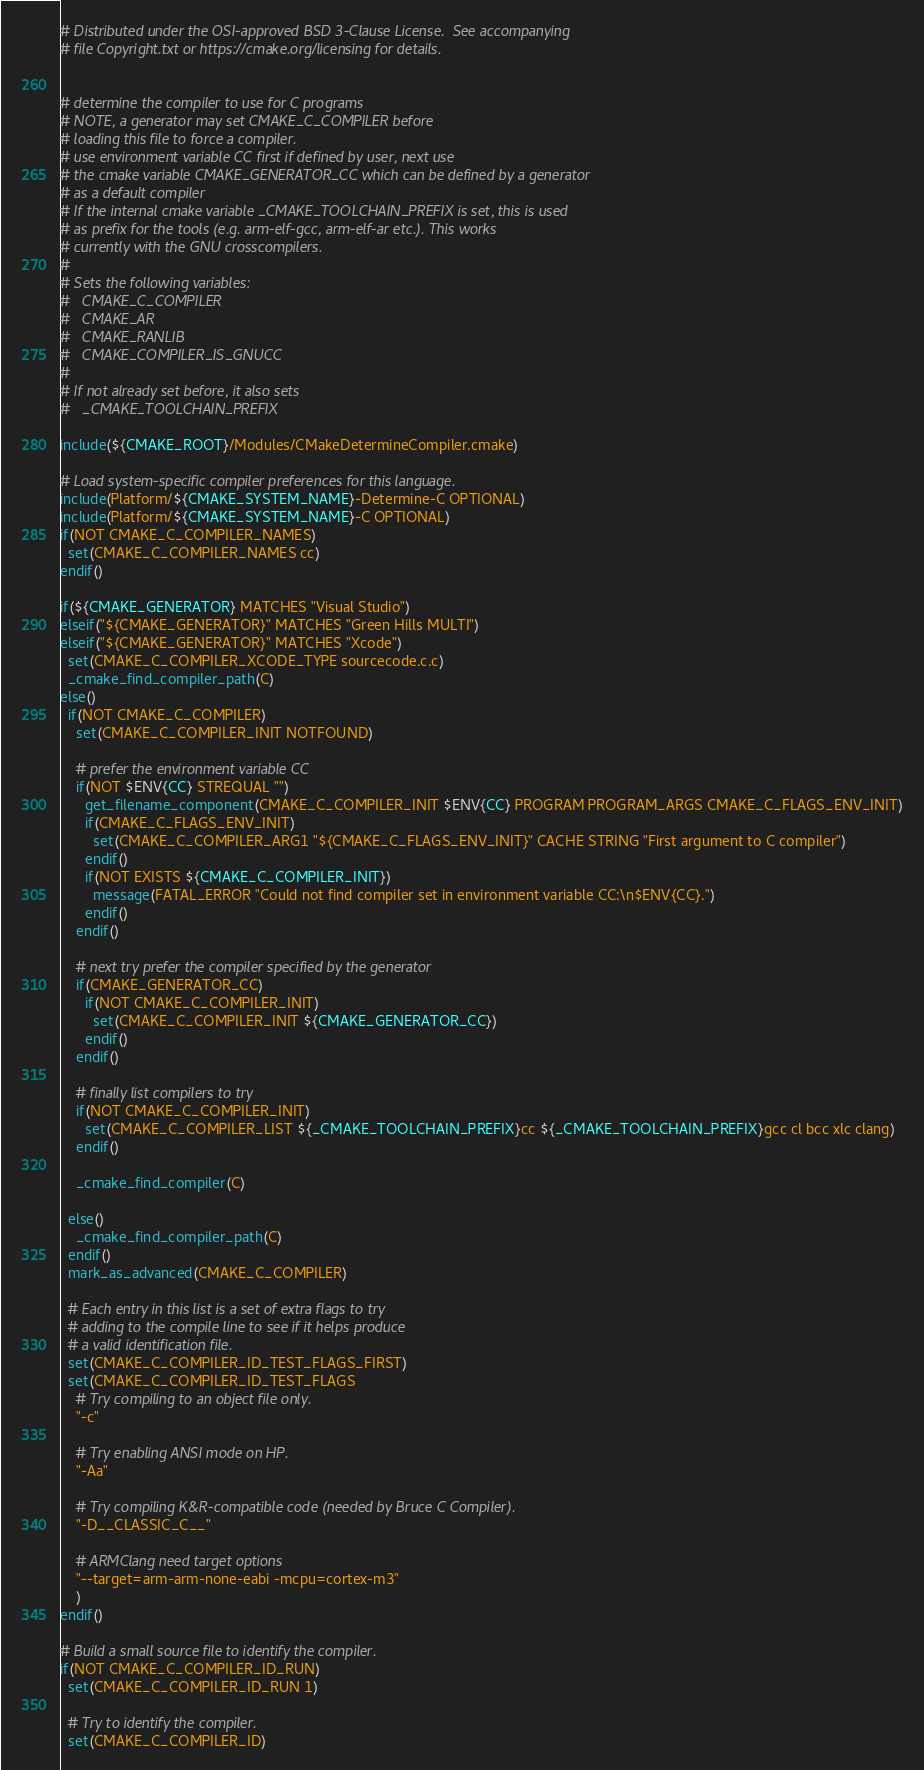<code> <loc_0><loc_0><loc_500><loc_500><_CMake_># Distributed under the OSI-approved BSD 3-Clause License.  See accompanying
# file Copyright.txt or https://cmake.org/licensing for details.


# determine the compiler to use for C programs
# NOTE, a generator may set CMAKE_C_COMPILER before
# loading this file to force a compiler.
# use environment variable CC first if defined by user, next use
# the cmake variable CMAKE_GENERATOR_CC which can be defined by a generator
# as a default compiler
# If the internal cmake variable _CMAKE_TOOLCHAIN_PREFIX is set, this is used
# as prefix for the tools (e.g. arm-elf-gcc, arm-elf-ar etc.). This works
# currently with the GNU crosscompilers.
#
# Sets the following variables:
#   CMAKE_C_COMPILER
#   CMAKE_AR
#   CMAKE_RANLIB
#   CMAKE_COMPILER_IS_GNUCC
#
# If not already set before, it also sets
#   _CMAKE_TOOLCHAIN_PREFIX

include(${CMAKE_ROOT}/Modules/CMakeDetermineCompiler.cmake)

# Load system-specific compiler preferences for this language.
include(Platform/${CMAKE_SYSTEM_NAME}-Determine-C OPTIONAL)
include(Platform/${CMAKE_SYSTEM_NAME}-C OPTIONAL)
if(NOT CMAKE_C_COMPILER_NAMES)
  set(CMAKE_C_COMPILER_NAMES cc)
endif()

if(${CMAKE_GENERATOR} MATCHES "Visual Studio")
elseif("${CMAKE_GENERATOR}" MATCHES "Green Hills MULTI")
elseif("${CMAKE_GENERATOR}" MATCHES "Xcode")
  set(CMAKE_C_COMPILER_XCODE_TYPE sourcecode.c.c)
  _cmake_find_compiler_path(C)
else()
  if(NOT CMAKE_C_COMPILER)
    set(CMAKE_C_COMPILER_INIT NOTFOUND)

    # prefer the environment variable CC
    if(NOT $ENV{CC} STREQUAL "")
      get_filename_component(CMAKE_C_COMPILER_INIT $ENV{CC} PROGRAM PROGRAM_ARGS CMAKE_C_FLAGS_ENV_INIT)
      if(CMAKE_C_FLAGS_ENV_INIT)
        set(CMAKE_C_COMPILER_ARG1 "${CMAKE_C_FLAGS_ENV_INIT}" CACHE STRING "First argument to C compiler")
      endif()
      if(NOT EXISTS ${CMAKE_C_COMPILER_INIT})
        message(FATAL_ERROR "Could not find compiler set in environment variable CC:\n$ENV{CC}.")
      endif()
    endif()

    # next try prefer the compiler specified by the generator
    if(CMAKE_GENERATOR_CC)
      if(NOT CMAKE_C_COMPILER_INIT)
        set(CMAKE_C_COMPILER_INIT ${CMAKE_GENERATOR_CC})
      endif()
    endif()

    # finally list compilers to try
    if(NOT CMAKE_C_COMPILER_INIT)
      set(CMAKE_C_COMPILER_LIST ${_CMAKE_TOOLCHAIN_PREFIX}cc ${_CMAKE_TOOLCHAIN_PREFIX}gcc cl bcc xlc clang)
    endif()

    _cmake_find_compiler(C)

  else()
    _cmake_find_compiler_path(C)
  endif()
  mark_as_advanced(CMAKE_C_COMPILER)

  # Each entry in this list is a set of extra flags to try
  # adding to the compile line to see if it helps produce
  # a valid identification file.
  set(CMAKE_C_COMPILER_ID_TEST_FLAGS_FIRST)
  set(CMAKE_C_COMPILER_ID_TEST_FLAGS
    # Try compiling to an object file only.
    "-c"

    # Try enabling ANSI mode on HP.
    "-Aa"

    # Try compiling K&R-compatible code (needed by Bruce C Compiler).
    "-D__CLASSIC_C__"

    # ARMClang need target options
    "--target=arm-arm-none-eabi -mcpu=cortex-m3"
    )
endif()

# Build a small source file to identify the compiler.
if(NOT CMAKE_C_COMPILER_ID_RUN)
  set(CMAKE_C_COMPILER_ID_RUN 1)

  # Try to identify the compiler.
  set(CMAKE_C_COMPILER_ID)</code> 